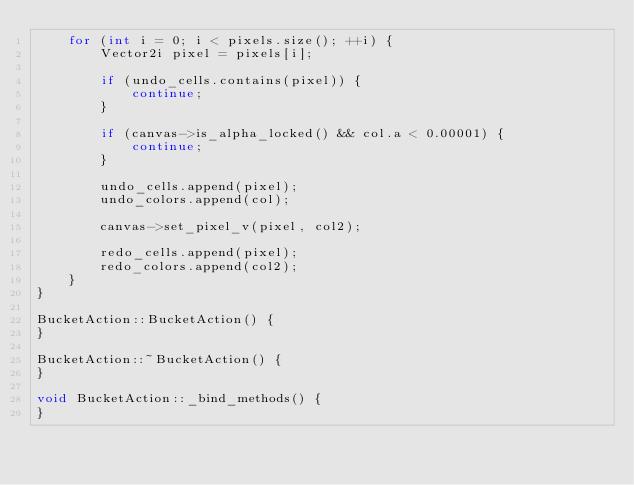Convert code to text. <code><loc_0><loc_0><loc_500><loc_500><_C++_>	for (int i = 0; i < pixels.size(); ++i) {
		Vector2i pixel = pixels[i];

		if (undo_cells.contains(pixel)) {
			continue;
		}

		if (canvas->is_alpha_locked() && col.a < 0.00001) {
			continue;
		}

		undo_cells.append(pixel);
		undo_colors.append(col);

		canvas->set_pixel_v(pixel, col2);

		redo_cells.append(pixel);
		redo_colors.append(col2);
	}
}

BucketAction::BucketAction() {
}

BucketAction::~BucketAction() {
}

void BucketAction::_bind_methods() {
}
</code> 